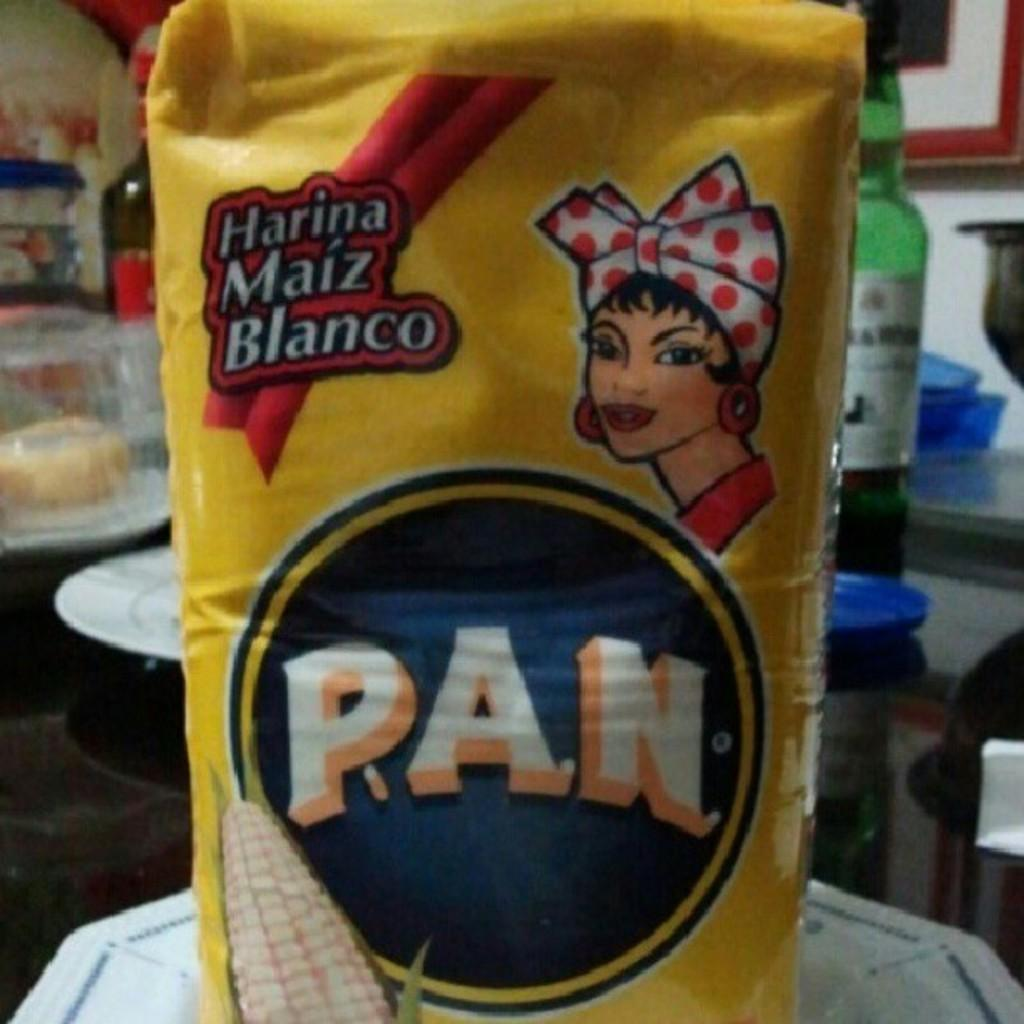<image>
Describe the image concisely. a bag of Pan with a lady wearing a polka dot head covering is on the plate 